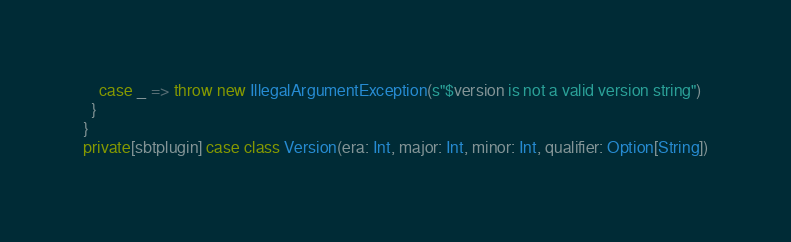<code> <loc_0><loc_0><loc_500><loc_500><_Scala_>    case _ => throw new IllegalArgumentException(s"$version is not a valid version string")
  }
}
private[sbtplugin] case class Version(era: Int, major: Int, minor: Int, qualifier: Option[String])
</code> 